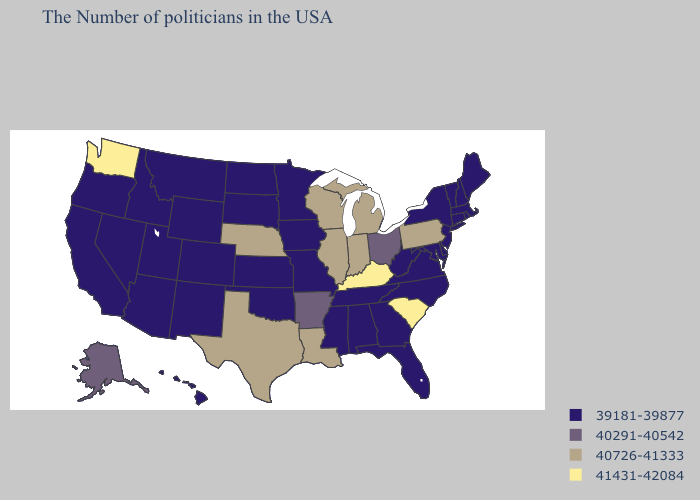What is the highest value in the Northeast ?
Short answer required. 40726-41333. Does Washington have the lowest value in the USA?
Short answer required. No. Name the states that have a value in the range 40726-41333?
Short answer required. Pennsylvania, Michigan, Indiana, Wisconsin, Illinois, Louisiana, Nebraska, Texas. What is the value of Alabama?
Answer briefly. 39181-39877. Name the states that have a value in the range 40291-40542?
Short answer required. Ohio, Arkansas, Alaska. What is the highest value in states that border Ohio?
Write a very short answer. 41431-42084. What is the highest value in the South ?
Answer briefly. 41431-42084. Name the states that have a value in the range 40291-40542?
Answer briefly. Ohio, Arkansas, Alaska. Which states have the lowest value in the USA?
Keep it brief. Maine, Massachusetts, Rhode Island, New Hampshire, Vermont, Connecticut, New York, New Jersey, Delaware, Maryland, Virginia, North Carolina, West Virginia, Florida, Georgia, Alabama, Tennessee, Mississippi, Missouri, Minnesota, Iowa, Kansas, Oklahoma, South Dakota, North Dakota, Wyoming, Colorado, New Mexico, Utah, Montana, Arizona, Idaho, Nevada, California, Oregon, Hawaii. What is the highest value in the MidWest ?
Be succinct. 40726-41333. Which states hav the highest value in the South?
Give a very brief answer. South Carolina, Kentucky. Is the legend a continuous bar?
Give a very brief answer. No. What is the value of Rhode Island?
Quick response, please. 39181-39877. What is the value of North Carolina?
Write a very short answer. 39181-39877. Name the states that have a value in the range 39181-39877?
Answer briefly. Maine, Massachusetts, Rhode Island, New Hampshire, Vermont, Connecticut, New York, New Jersey, Delaware, Maryland, Virginia, North Carolina, West Virginia, Florida, Georgia, Alabama, Tennessee, Mississippi, Missouri, Minnesota, Iowa, Kansas, Oklahoma, South Dakota, North Dakota, Wyoming, Colorado, New Mexico, Utah, Montana, Arizona, Idaho, Nevada, California, Oregon, Hawaii. 